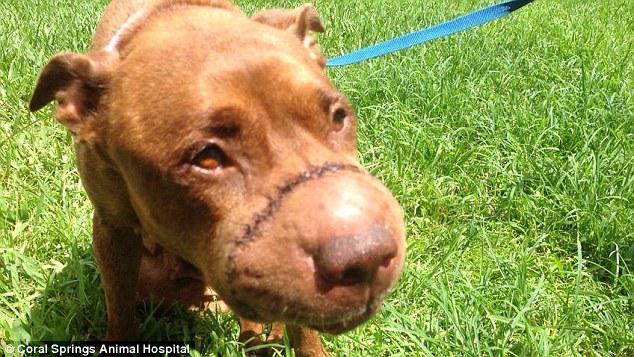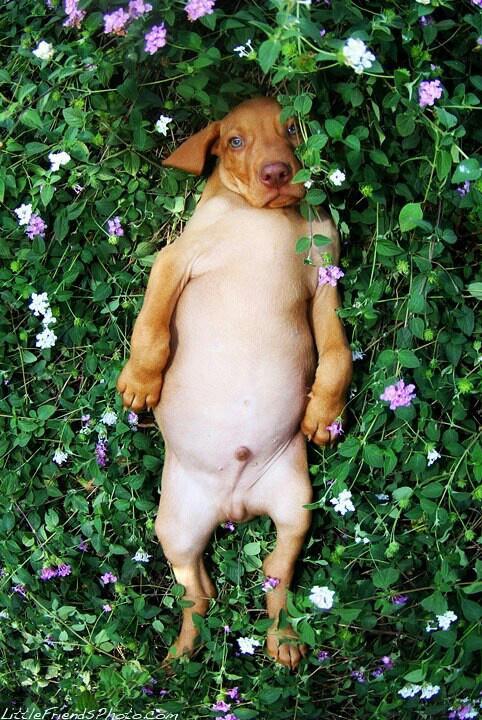The first image is the image on the left, the second image is the image on the right. Evaluate the accuracy of this statement regarding the images: "The dog in the image on the left is standing in the grass.". Is it true? Answer yes or no. Yes. The first image is the image on the left, the second image is the image on the right. Evaluate the accuracy of this statement regarding the images: "Each image contains exactly one red-orange dog, one image shows a puppy headed across the grass with a front paw raised, and the other shows a dog wearing a bluish collar.". Is it true? Answer yes or no. No. 